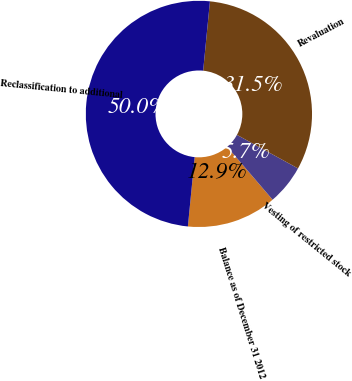<chart> <loc_0><loc_0><loc_500><loc_500><pie_chart><fcel>Balance as of December 31 2012<fcel>Vesting of restricted stock<fcel>Revaluation<fcel>Reclassification to additional<nl><fcel>12.85%<fcel>5.7%<fcel>31.45%<fcel>50.0%<nl></chart> 